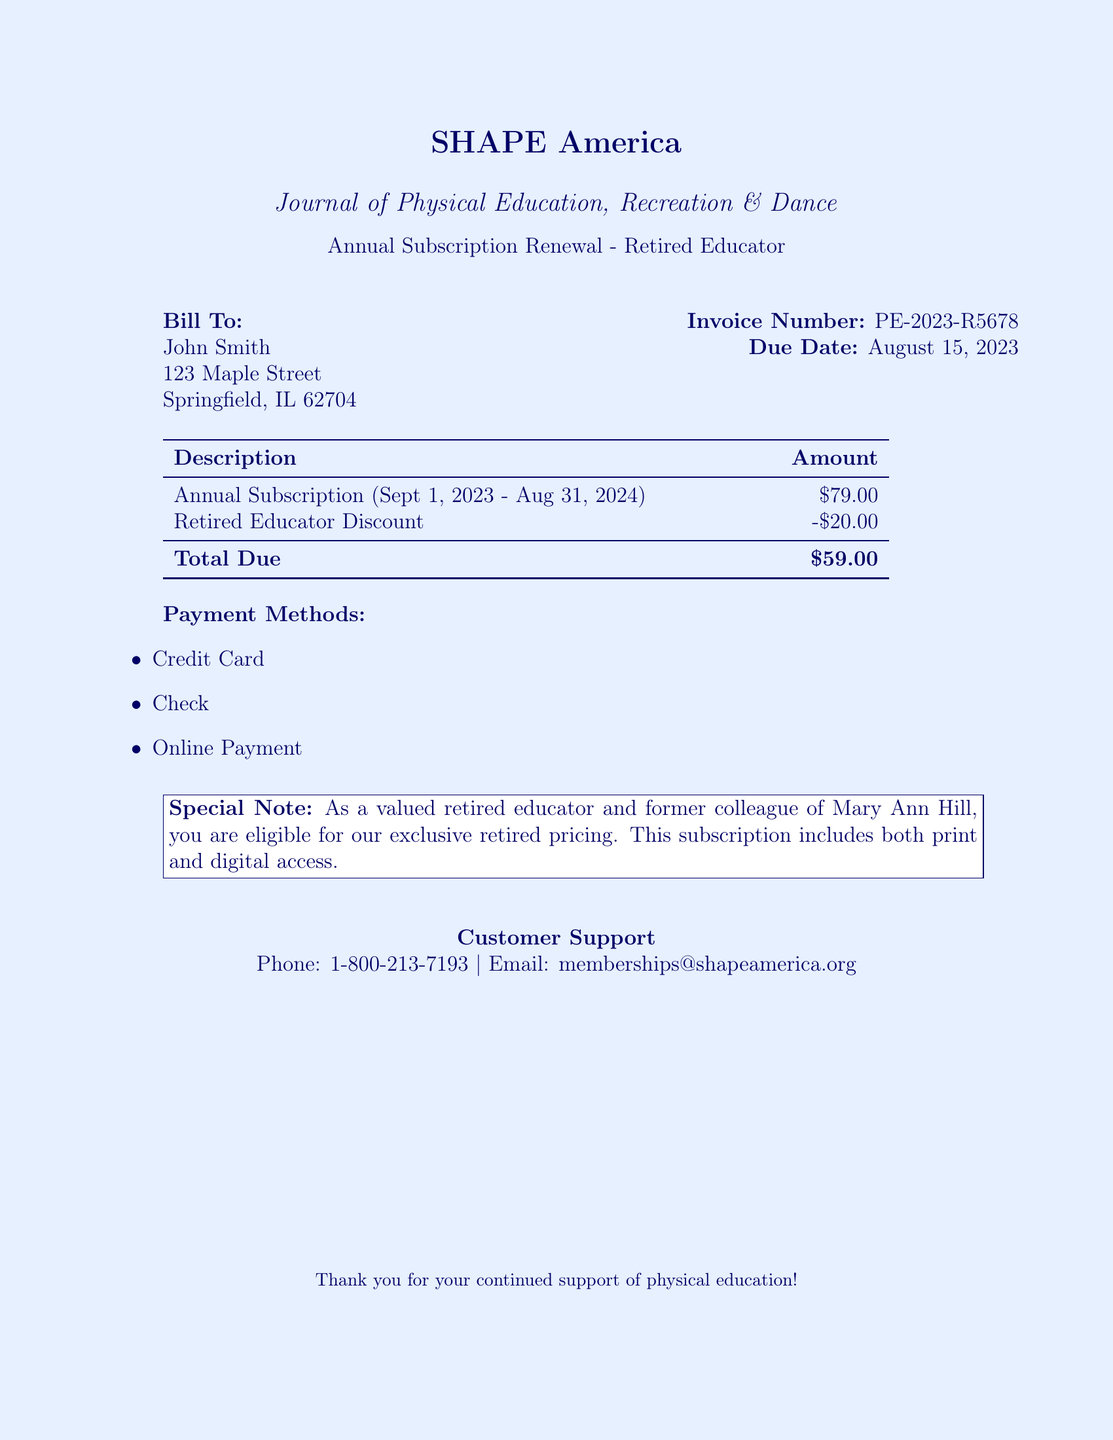What is the invoice number? The invoice number is listed in the document for reference, which is PE-2023-R5678.
Answer: PE-2023-R5678 What is the total amount due? The total amount due is calculated after applying discounts, which is $79.00 - $20.00 = $59.00.
Answer: $59.00 What is the due date? The due date for the payment is specified in the document, which is August 15, 2023.
Answer: August 15, 2023 What type of journal is this subscription for? The type of journal associated with the subscription is mentioned, which is the Journal of Physical Education, Recreation & Dance.
Answer: Journal of Physical Education, Recreation & Dance What discount is applied to the annual subscription? The document states the discount provided for retired educators, which is $20.00.
Answer: $20.00 Who is the bill addressed to? The bill addresses a specific individual, which is John Smith.
Answer: John Smith What is the payment method mentioned? The document lists available payment methods for the subscription, including credit card, check, and online payment.
Answer: Credit Card What special note is included in the document? The document contains a special note about eligibility for retired pricing and that the subscription includes print and digital access.
Answer: Exclusive retired pricing How long is the subscription period? The duration of the subscription is explicitly stated in the document, which is from September 1, 2023, to August 31, 2024.
Answer: September 1, 2023 - August 31, 2024 